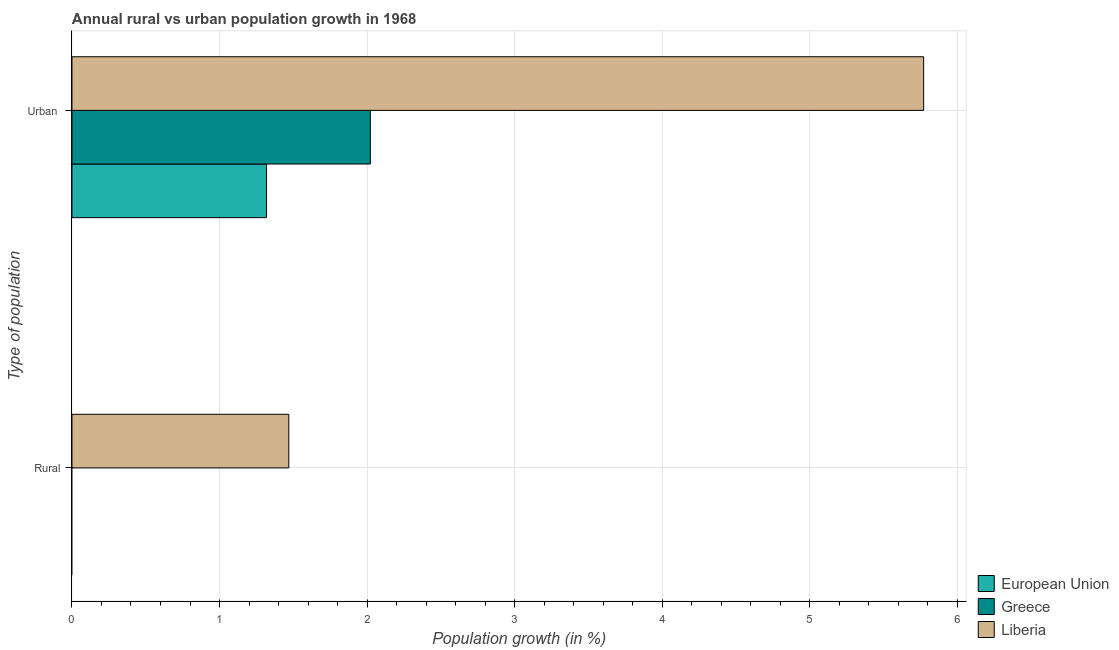Are the number of bars per tick equal to the number of legend labels?
Provide a short and direct response. No. How many bars are there on the 2nd tick from the bottom?
Your answer should be compact. 3. What is the label of the 2nd group of bars from the top?
Offer a very short reply. Rural. What is the urban population growth in Liberia?
Offer a very short reply. 5.77. Across all countries, what is the maximum urban population growth?
Make the answer very short. 5.77. Across all countries, what is the minimum rural population growth?
Make the answer very short. 0. In which country was the urban population growth maximum?
Give a very brief answer. Liberia. What is the total urban population growth in the graph?
Offer a very short reply. 9.11. What is the difference between the urban population growth in Liberia and that in European Union?
Ensure brevity in your answer.  4.45. What is the difference between the urban population growth in Greece and the rural population growth in European Union?
Your answer should be compact. 2.02. What is the average rural population growth per country?
Provide a succinct answer. 0.49. What is the difference between the rural population growth and urban population growth in Liberia?
Make the answer very short. -4.3. What is the ratio of the urban population growth in Greece to that in European Union?
Provide a short and direct response. 1.53. How many bars are there?
Give a very brief answer. 4. How many countries are there in the graph?
Provide a short and direct response. 3. What is the difference between two consecutive major ticks on the X-axis?
Your response must be concise. 1. Are the values on the major ticks of X-axis written in scientific E-notation?
Keep it short and to the point. No. Does the graph contain any zero values?
Your response must be concise. Yes. Does the graph contain grids?
Ensure brevity in your answer.  Yes. How are the legend labels stacked?
Ensure brevity in your answer.  Vertical. What is the title of the graph?
Your answer should be very brief. Annual rural vs urban population growth in 1968. Does "Antigua and Barbuda" appear as one of the legend labels in the graph?
Ensure brevity in your answer.  No. What is the label or title of the X-axis?
Provide a short and direct response. Population growth (in %). What is the label or title of the Y-axis?
Make the answer very short. Type of population. What is the Population growth (in %) in Liberia in Rural?
Provide a short and direct response. 1.47. What is the Population growth (in %) of European Union in Urban ?
Keep it short and to the point. 1.32. What is the Population growth (in %) in Greece in Urban ?
Give a very brief answer. 2.02. What is the Population growth (in %) in Liberia in Urban ?
Your answer should be very brief. 5.77. Across all Type of population, what is the maximum Population growth (in %) of European Union?
Make the answer very short. 1.32. Across all Type of population, what is the maximum Population growth (in %) of Greece?
Provide a short and direct response. 2.02. Across all Type of population, what is the maximum Population growth (in %) in Liberia?
Make the answer very short. 5.77. Across all Type of population, what is the minimum Population growth (in %) in European Union?
Your answer should be compact. 0. Across all Type of population, what is the minimum Population growth (in %) of Liberia?
Offer a terse response. 1.47. What is the total Population growth (in %) in European Union in the graph?
Offer a terse response. 1.32. What is the total Population growth (in %) of Greece in the graph?
Your response must be concise. 2.02. What is the total Population growth (in %) of Liberia in the graph?
Your response must be concise. 7.24. What is the difference between the Population growth (in %) in Liberia in Rural and that in Urban ?
Offer a very short reply. -4.3. What is the average Population growth (in %) in European Union per Type of population?
Provide a short and direct response. 0.66. What is the average Population growth (in %) in Greece per Type of population?
Ensure brevity in your answer.  1.01. What is the average Population growth (in %) in Liberia per Type of population?
Give a very brief answer. 3.62. What is the difference between the Population growth (in %) of European Union and Population growth (in %) of Greece in Urban ?
Offer a terse response. -0.7. What is the difference between the Population growth (in %) in European Union and Population growth (in %) in Liberia in Urban ?
Offer a very short reply. -4.45. What is the difference between the Population growth (in %) in Greece and Population growth (in %) in Liberia in Urban ?
Keep it short and to the point. -3.75. What is the ratio of the Population growth (in %) in Liberia in Rural to that in Urban ?
Your response must be concise. 0.25. What is the difference between the highest and the second highest Population growth (in %) in Liberia?
Provide a succinct answer. 4.3. What is the difference between the highest and the lowest Population growth (in %) of European Union?
Offer a terse response. 1.32. What is the difference between the highest and the lowest Population growth (in %) in Greece?
Provide a short and direct response. 2.02. What is the difference between the highest and the lowest Population growth (in %) in Liberia?
Provide a succinct answer. 4.3. 